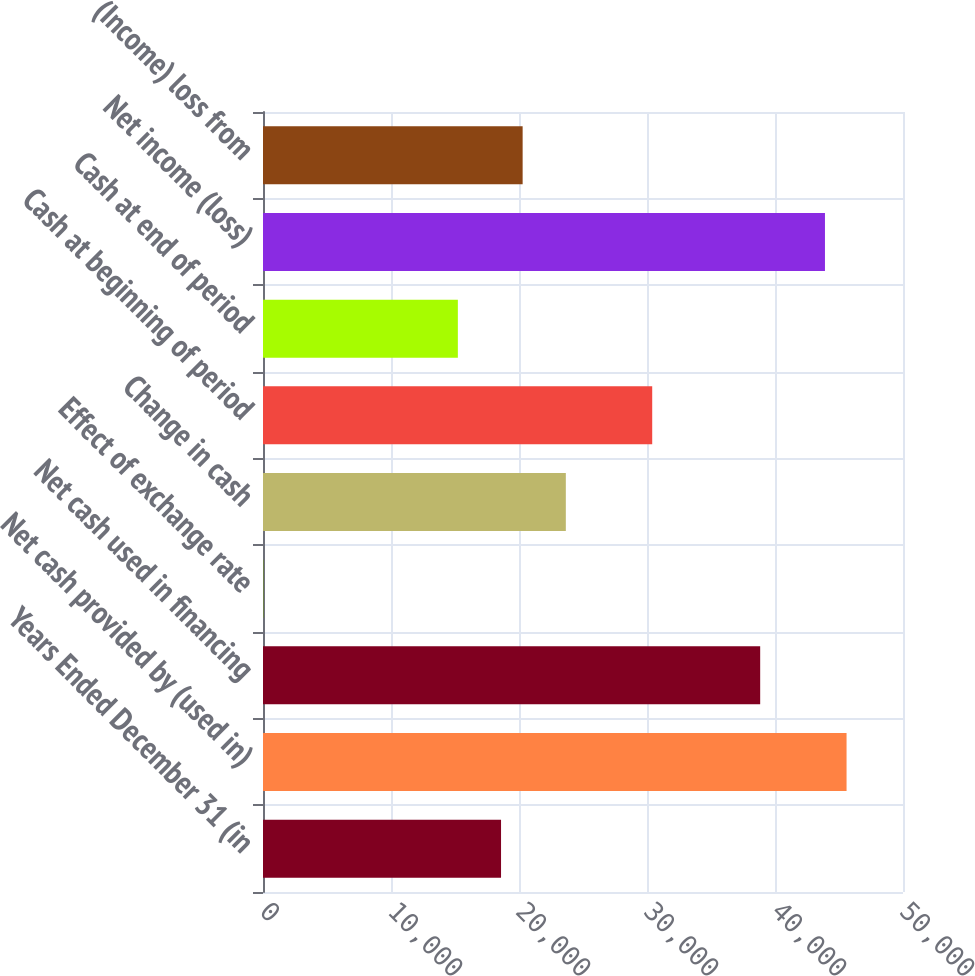Convert chart to OTSL. <chart><loc_0><loc_0><loc_500><loc_500><bar_chart><fcel>Years Ended December 31 (in<fcel>Net cash provided by (used in)<fcel>Net cash used in financing<fcel>Effect of exchange rate<fcel>Change in cash<fcel>Cash at beginning of period<fcel>Cash at end of period<fcel>Net income (loss)<fcel>(Income) loss from<nl><fcel>18597.1<fcel>45590.7<fcel>38842.3<fcel>39<fcel>23658.4<fcel>30406.8<fcel>15222.9<fcel>43903.6<fcel>20284.2<nl></chart> 